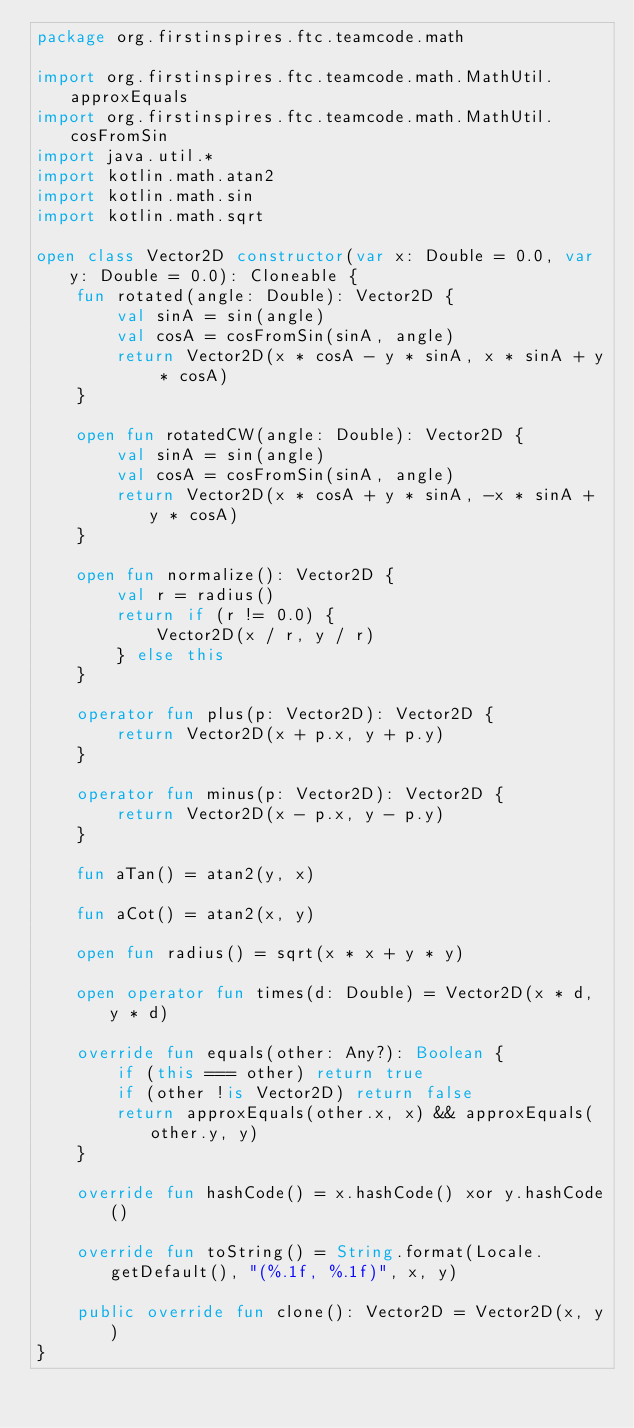Convert code to text. <code><loc_0><loc_0><loc_500><loc_500><_Kotlin_>package org.firstinspires.ftc.teamcode.math

import org.firstinspires.ftc.teamcode.math.MathUtil.approxEquals
import org.firstinspires.ftc.teamcode.math.MathUtil.cosFromSin
import java.util.*
import kotlin.math.atan2
import kotlin.math.sin
import kotlin.math.sqrt

open class Vector2D constructor(var x: Double = 0.0, var y: Double = 0.0): Cloneable {
    fun rotated(angle: Double): Vector2D {
        val sinA = sin(angle)
        val cosA = cosFromSin(sinA, angle)
        return Vector2D(x * cosA - y * sinA, x * sinA + y * cosA)
    }

    open fun rotatedCW(angle: Double): Vector2D {
        val sinA = sin(angle)
        val cosA = cosFromSin(sinA, angle)
        return Vector2D(x * cosA + y * sinA, -x * sinA + y * cosA)
    }

    open fun normalize(): Vector2D {
        val r = radius()
        return if (r != 0.0) {
            Vector2D(x / r, y / r)
        } else this
    }

    operator fun plus(p: Vector2D): Vector2D {
        return Vector2D(x + p.x, y + p.y)
    }

    operator fun minus(p: Vector2D): Vector2D {
        return Vector2D(x - p.x, y - p.y)
    }

    fun aTan() = atan2(y, x)

    fun aCot() = atan2(x, y)

    open fun radius() = sqrt(x * x + y * y)

    open operator fun times(d: Double) = Vector2D(x * d, y * d)

    override fun equals(other: Any?): Boolean {
        if (this === other) return true
        if (other !is Vector2D) return false
        return approxEquals(other.x, x) && approxEquals(other.y, y)
    }

    override fun hashCode() = x.hashCode() xor y.hashCode()

    override fun toString() = String.format(Locale.getDefault(), "(%.1f, %.1f)", x, y)

    public override fun clone(): Vector2D = Vector2D(x, y)
}</code> 